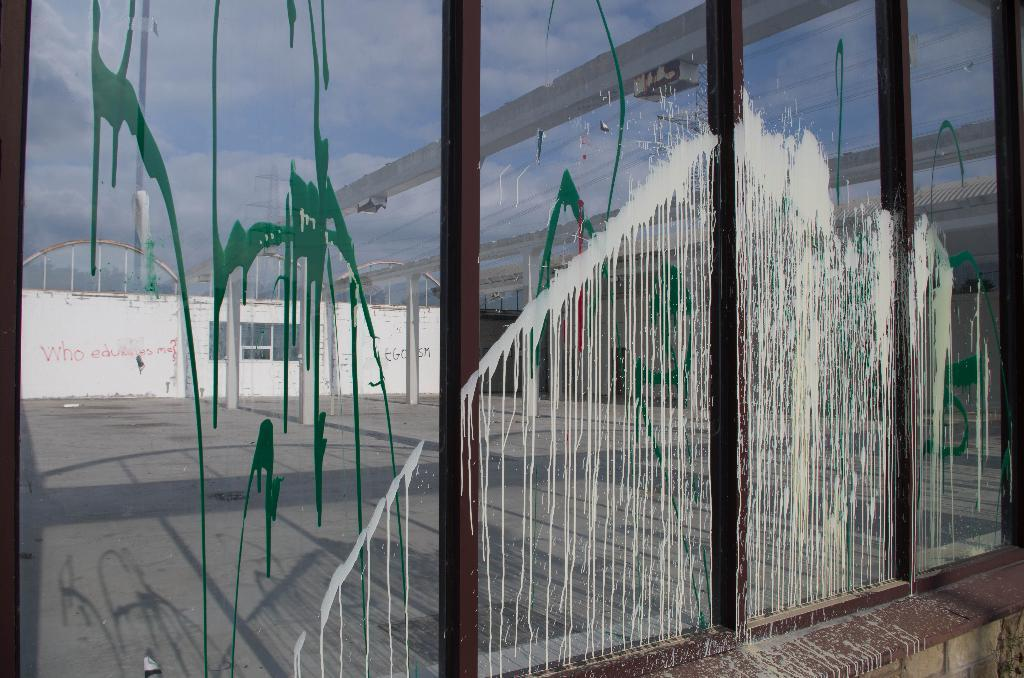What object is visible in the image that can hold a liquid? There is a glass in the image. What can be seen through the glass in the image? The glass allows for the view of a wall and the sky. What is on the surface of the glass? There is a painting on the glass. What type of shirt is hanging on the mailbox in the image? There is no shirt or mailbox present in the image. 